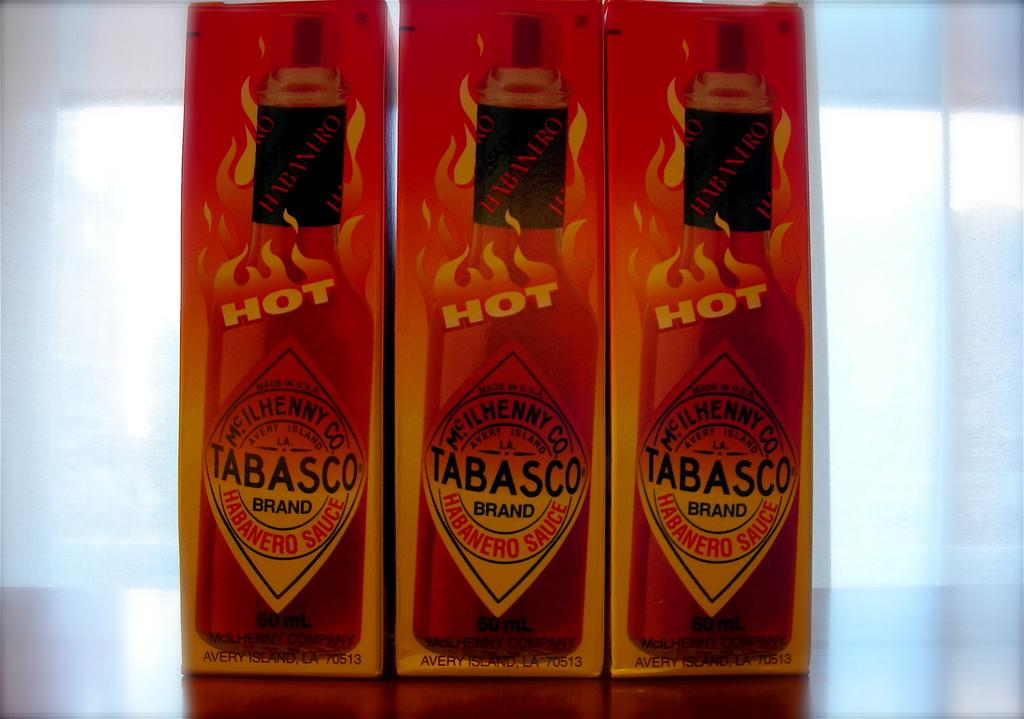<image>
Share a concise interpretation of the image provided. Three boxes of Tabasco sauce are lined up on a surface. 